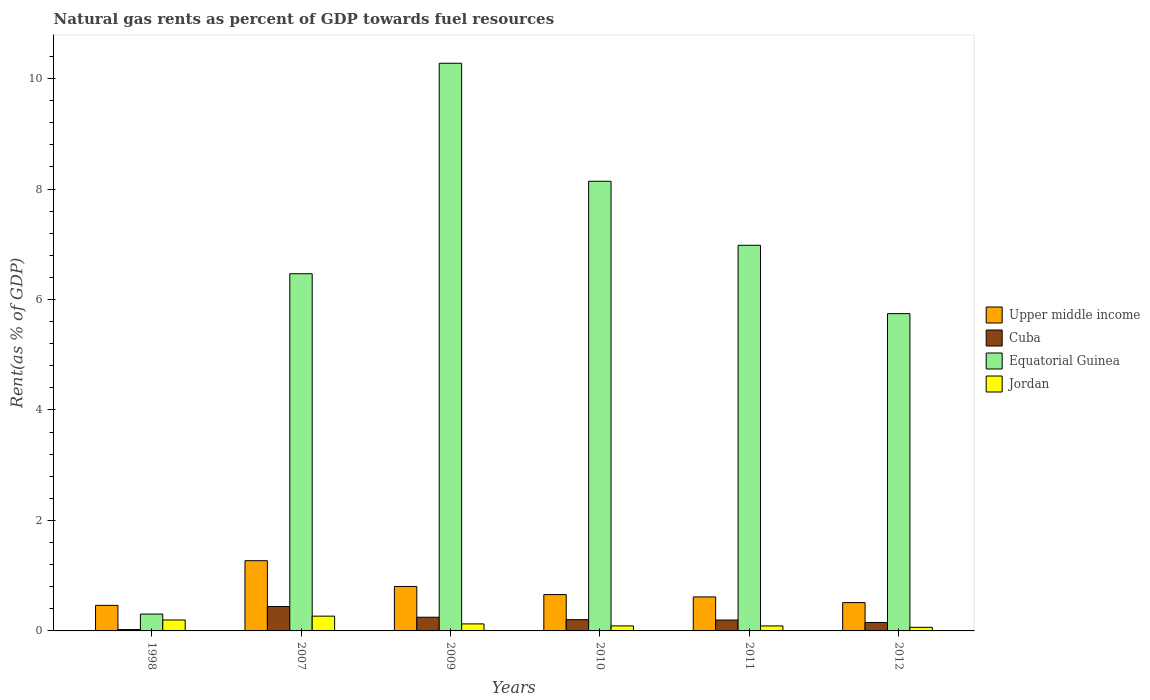How many different coloured bars are there?
Provide a succinct answer. 4. How many groups of bars are there?
Your response must be concise. 6. Are the number of bars per tick equal to the number of legend labels?
Your answer should be very brief. Yes. In how many cases, is the number of bars for a given year not equal to the number of legend labels?
Ensure brevity in your answer.  0. What is the matural gas rent in Cuba in 2010?
Provide a short and direct response. 0.2. Across all years, what is the maximum matural gas rent in Upper middle income?
Your answer should be very brief. 1.27. Across all years, what is the minimum matural gas rent in Equatorial Guinea?
Your answer should be compact. 0.31. In which year was the matural gas rent in Cuba maximum?
Your response must be concise. 2007. What is the total matural gas rent in Jordan in the graph?
Offer a very short reply. 0.84. What is the difference between the matural gas rent in Upper middle income in 2010 and that in 2011?
Your response must be concise. 0.04. What is the difference between the matural gas rent in Jordan in 2007 and the matural gas rent in Equatorial Guinea in 2012?
Your answer should be compact. -5.48. What is the average matural gas rent in Jordan per year?
Ensure brevity in your answer.  0.14. In the year 2007, what is the difference between the matural gas rent in Upper middle income and matural gas rent in Equatorial Guinea?
Offer a very short reply. -5.2. In how many years, is the matural gas rent in Equatorial Guinea greater than 2 %?
Provide a succinct answer. 5. What is the ratio of the matural gas rent in Jordan in 2011 to that in 2012?
Your response must be concise. 1.38. Is the matural gas rent in Equatorial Guinea in 2007 less than that in 2011?
Your answer should be compact. Yes. Is the difference between the matural gas rent in Upper middle income in 1998 and 2010 greater than the difference between the matural gas rent in Equatorial Guinea in 1998 and 2010?
Make the answer very short. Yes. What is the difference between the highest and the second highest matural gas rent in Equatorial Guinea?
Your answer should be very brief. 2.14. What is the difference between the highest and the lowest matural gas rent in Jordan?
Keep it short and to the point. 0.2. What does the 4th bar from the left in 2007 represents?
Your answer should be compact. Jordan. What does the 4th bar from the right in 1998 represents?
Provide a succinct answer. Upper middle income. How many bars are there?
Offer a terse response. 24. Does the graph contain any zero values?
Keep it short and to the point. No. Does the graph contain grids?
Make the answer very short. No. Where does the legend appear in the graph?
Provide a succinct answer. Center right. How are the legend labels stacked?
Give a very brief answer. Vertical. What is the title of the graph?
Ensure brevity in your answer.  Natural gas rents as percent of GDP towards fuel resources. Does "Cayman Islands" appear as one of the legend labels in the graph?
Keep it short and to the point. No. What is the label or title of the X-axis?
Provide a succinct answer. Years. What is the label or title of the Y-axis?
Provide a succinct answer. Rent(as % of GDP). What is the Rent(as % of GDP) of Upper middle income in 1998?
Your response must be concise. 0.46. What is the Rent(as % of GDP) in Cuba in 1998?
Make the answer very short. 0.02. What is the Rent(as % of GDP) in Equatorial Guinea in 1998?
Ensure brevity in your answer.  0.31. What is the Rent(as % of GDP) of Jordan in 1998?
Ensure brevity in your answer.  0.2. What is the Rent(as % of GDP) in Upper middle income in 2007?
Ensure brevity in your answer.  1.27. What is the Rent(as % of GDP) of Cuba in 2007?
Your answer should be very brief. 0.44. What is the Rent(as % of GDP) of Equatorial Guinea in 2007?
Keep it short and to the point. 6.47. What is the Rent(as % of GDP) in Jordan in 2007?
Give a very brief answer. 0.27. What is the Rent(as % of GDP) of Upper middle income in 2009?
Keep it short and to the point. 0.8. What is the Rent(as % of GDP) of Cuba in 2009?
Ensure brevity in your answer.  0.25. What is the Rent(as % of GDP) in Equatorial Guinea in 2009?
Provide a short and direct response. 10.28. What is the Rent(as % of GDP) in Jordan in 2009?
Provide a succinct answer. 0.13. What is the Rent(as % of GDP) of Upper middle income in 2010?
Your answer should be compact. 0.66. What is the Rent(as % of GDP) in Cuba in 2010?
Offer a very short reply. 0.2. What is the Rent(as % of GDP) of Equatorial Guinea in 2010?
Provide a short and direct response. 8.14. What is the Rent(as % of GDP) in Jordan in 2010?
Your response must be concise. 0.09. What is the Rent(as % of GDP) in Upper middle income in 2011?
Keep it short and to the point. 0.62. What is the Rent(as % of GDP) in Cuba in 2011?
Give a very brief answer. 0.2. What is the Rent(as % of GDP) of Equatorial Guinea in 2011?
Your answer should be very brief. 6.98. What is the Rent(as % of GDP) in Jordan in 2011?
Your answer should be very brief. 0.09. What is the Rent(as % of GDP) of Upper middle income in 2012?
Provide a short and direct response. 0.51. What is the Rent(as % of GDP) in Cuba in 2012?
Make the answer very short. 0.15. What is the Rent(as % of GDP) in Equatorial Guinea in 2012?
Provide a succinct answer. 5.74. What is the Rent(as % of GDP) of Jordan in 2012?
Your answer should be very brief. 0.07. Across all years, what is the maximum Rent(as % of GDP) in Upper middle income?
Provide a short and direct response. 1.27. Across all years, what is the maximum Rent(as % of GDP) in Cuba?
Your response must be concise. 0.44. Across all years, what is the maximum Rent(as % of GDP) of Equatorial Guinea?
Provide a succinct answer. 10.28. Across all years, what is the maximum Rent(as % of GDP) of Jordan?
Ensure brevity in your answer.  0.27. Across all years, what is the minimum Rent(as % of GDP) of Upper middle income?
Your answer should be compact. 0.46. Across all years, what is the minimum Rent(as % of GDP) in Cuba?
Provide a succinct answer. 0.02. Across all years, what is the minimum Rent(as % of GDP) in Equatorial Guinea?
Your response must be concise. 0.31. Across all years, what is the minimum Rent(as % of GDP) in Jordan?
Make the answer very short. 0.07. What is the total Rent(as % of GDP) of Upper middle income in the graph?
Provide a short and direct response. 4.33. What is the total Rent(as % of GDP) in Cuba in the graph?
Ensure brevity in your answer.  1.27. What is the total Rent(as % of GDP) in Equatorial Guinea in the graph?
Provide a succinct answer. 37.92. What is the total Rent(as % of GDP) of Jordan in the graph?
Ensure brevity in your answer.  0.84. What is the difference between the Rent(as % of GDP) of Upper middle income in 1998 and that in 2007?
Provide a short and direct response. -0.81. What is the difference between the Rent(as % of GDP) of Cuba in 1998 and that in 2007?
Keep it short and to the point. -0.42. What is the difference between the Rent(as % of GDP) in Equatorial Guinea in 1998 and that in 2007?
Your response must be concise. -6.16. What is the difference between the Rent(as % of GDP) in Jordan in 1998 and that in 2007?
Your answer should be compact. -0.07. What is the difference between the Rent(as % of GDP) of Upper middle income in 1998 and that in 2009?
Ensure brevity in your answer.  -0.34. What is the difference between the Rent(as % of GDP) of Cuba in 1998 and that in 2009?
Offer a terse response. -0.22. What is the difference between the Rent(as % of GDP) of Equatorial Guinea in 1998 and that in 2009?
Your response must be concise. -9.97. What is the difference between the Rent(as % of GDP) in Jordan in 1998 and that in 2009?
Offer a terse response. 0.07. What is the difference between the Rent(as % of GDP) of Upper middle income in 1998 and that in 2010?
Give a very brief answer. -0.2. What is the difference between the Rent(as % of GDP) in Cuba in 1998 and that in 2010?
Ensure brevity in your answer.  -0.18. What is the difference between the Rent(as % of GDP) of Equatorial Guinea in 1998 and that in 2010?
Keep it short and to the point. -7.84. What is the difference between the Rent(as % of GDP) of Jordan in 1998 and that in 2010?
Offer a terse response. 0.11. What is the difference between the Rent(as % of GDP) of Upper middle income in 1998 and that in 2011?
Offer a very short reply. -0.15. What is the difference between the Rent(as % of GDP) of Cuba in 1998 and that in 2011?
Make the answer very short. -0.17. What is the difference between the Rent(as % of GDP) in Equatorial Guinea in 1998 and that in 2011?
Your answer should be very brief. -6.68. What is the difference between the Rent(as % of GDP) of Jordan in 1998 and that in 2011?
Your answer should be very brief. 0.11. What is the difference between the Rent(as % of GDP) of Upper middle income in 1998 and that in 2012?
Provide a short and direct response. -0.05. What is the difference between the Rent(as % of GDP) of Cuba in 1998 and that in 2012?
Keep it short and to the point. -0.13. What is the difference between the Rent(as % of GDP) of Equatorial Guinea in 1998 and that in 2012?
Provide a short and direct response. -5.44. What is the difference between the Rent(as % of GDP) of Jordan in 1998 and that in 2012?
Your answer should be very brief. 0.13. What is the difference between the Rent(as % of GDP) of Upper middle income in 2007 and that in 2009?
Give a very brief answer. 0.47. What is the difference between the Rent(as % of GDP) of Cuba in 2007 and that in 2009?
Provide a succinct answer. 0.19. What is the difference between the Rent(as % of GDP) in Equatorial Guinea in 2007 and that in 2009?
Keep it short and to the point. -3.81. What is the difference between the Rent(as % of GDP) in Jordan in 2007 and that in 2009?
Your answer should be compact. 0.14. What is the difference between the Rent(as % of GDP) of Upper middle income in 2007 and that in 2010?
Offer a terse response. 0.61. What is the difference between the Rent(as % of GDP) in Cuba in 2007 and that in 2010?
Ensure brevity in your answer.  0.24. What is the difference between the Rent(as % of GDP) of Equatorial Guinea in 2007 and that in 2010?
Provide a short and direct response. -1.67. What is the difference between the Rent(as % of GDP) in Jordan in 2007 and that in 2010?
Give a very brief answer. 0.18. What is the difference between the Rent(as % of GDP) of Upper middle income in 2007 and that in 2011?
Keep it short and to the point. 0.66. What is the difference between the Rent(as % of GDP) in Cuba in 2007 and that in 2011?
Give a very brief answer. 0.24. What is the difference between the Rent(as % of GDP) in Equatorial Guinea in 2007 and that in 2011?
Give a very brief answer. -0.51. What is the difference between the Rent(as % of GDP) in Jordan in 2007 and that in 2011?
Ensure brevity in your answer.  0.18. What is the difference between the Rent(as % of GDP) in Upper middle income in 2007 and that in 2012?
Offer a terse response. 0.76. What is the difference between the Rent(as % of GDP) in Cuba in 2007 and that in 2012?
Give a very brief answer. 0.29. What is the difference between the Rent(as % of GDP) in Equatorial Guinea in 2007 and that in 2012?
Ensure brevity in your answer.  0.72. What is the difference between the Rent(as % of GDP) in Jordan in 2007 and that in 2012?
Provide a succinct answer. 0.2. What is the difference between the Rent(as % of GDP) in Upper middle income in 2009 and that in 2010?
Provide a succinct answer. 0.15. What is the difference between the Rent(as % of GDP) in Cuba in 2009 and that in 2010?
Offer a terse response. 0.04. What is the difference between the Rent(as % of GDP) of Equatorial Guinea in 2009 and that in 2010?
Your response must be concise. 2.14. What is the difference between the Rent(as % of GDP) in Jordan in 2009 and that in 2010?
Offer a terse response. 0.04. What is the difference between the Rent(as % of GDP) of Upper middle income in 2009 and that in 2011?
Give a very brief answer. 0.19. What is the difference between the Rent(as % of GDP) of Cuba in 2009 and that in 2011?
Offer a terse response. 0.05. What is the difference between the Rent(as % of GDP) of Equatorial Guinea in 2009 and that in 2011?
Provide a short and direct response. 3.3. What is the difference between the Rent(as % of GDP) of Jordan in 2009 and that in 2011?
Your response must be concise. 0.04. What is the difference between the Rent(as % of GDP) of Upper middle income in 2009 and that in 2012?
Provide a short and direct response. 0.29. What is the difference between the Rent(as % of GDP) of Cuba in 2009 and that in 2012?
Offer a very short reply. 0.1. What is the difference between the Rent(as % of GDP) in Equatorial Guinea in 2009 and that in 2012?
Make the answer very short. 4.53. What is the difference between the Rent(as % of GDP) in Jordan in 2009 and that in 2012?
Give a very brief answer. 0.06. What is the difference between the Rent(as % of GDP) of Upper middle income in 2010 and that in 2011?
Provide a short and direct response. 0.04. What is the difference between the Rent(as % of GDP) of Cuba in 2010 and that in 2011?
Offer a very short reply. 0.01. What is the difference between the Rent(as % of GDP) of Equatorial Guinea in 2010 and that in 2011?
Provide a succinct answer. 1.16. What is the difference between the Rent(as % of GDP) of Upper middle income in 2010 and that in 2012?
Your response must be concise. 0.15. What is the difference between the Rent(as % of GDP) in Cuba in 2010 and that in 2012?
Offer a terse response. 0.05. What is the difference between the Rent(as % of GDP) of Equatorial Guinea in 2010 and that in 2012?
Offer a very short reply. 2.4. What is the difference between the Rent(as % of GDP) in Jordan in 2010 and that in 2012?
Provide a succinct answer. 0.03. What is the difference between the Rent(as % of GDP) in Upper middle income in 2011 and that in 2012?
Offer a very short reply. 0.1. What is the difference between the Rent(as % of GDP) of Cuba in 2011 and that in 2012?
Give a very brief answer. 0.04. What is the difference between the Rent(as % of GDP) in Equatorial Guinea in 2011 and that in 2012?
Your answer should be compact. 1.24. What is the difference between the Rent(as % of GDP) in Jordan in 2011 and that in 2012?
Give a very brief answer. 0.02. What is the difference between the Rent(as % of GDP) in Upper middle income in 1998 and the Rent(as % of GDP) in Cuba in 2007?
Your response must be concise. 0.02. What is the difference between the Rent(as % of GDP) of Upper middle income in 1998 and the Rent(as % of GDP) of Equatorial Guinea in 2007?
Give a very brief answer. -6. What is the difference between the Rent(as % of GDP) of Upper middle income in 1998 and the Rent(as % of GDP) of Jordan in 2007?
Your answer should be very brief. 0.2. What is the difference between the Rent(as % of GDP) of Cuba in 1998 and the Rent(as % of GDP) of Equatorial Guinea in 2007?
Your response must be concise. -6.44. What is the difference between the Rent(as % of GDP) in Cuba in 1998 and the Rent(as % of GDP) in Jordan in 2007?
Make the answer very short. -0.24. What is the difference between the Rent(as % of GDP) of Equatorial Guinea in 1998 and the Rent(as % of GDP) of Jordan in 2007?
Your answer should be very brief. 0.04. What is the difference between the Rent(as % of GDP) of Upper middle income in 1998 and the Rent(as % of GDP) of Cuba in 2009?
Provide a succinct answer. 0.21. What is the difference between the Rent(as % of GDP) of Upper middle income in 1998 and the Rent(as % of GDP) of Equatorial Guinea in 2009?
Provide a short and direct response. -9.81. What is the difference between the Rent(as % of GDP) of Upper middle income in 1998 and the Rent(as % of GDP) of Jordan in 2009?
Your response must be concise. 0.34. What is the difference between the Rent(as % of GDP) in Cuba in 1998 and the Rent(as % of GDP) in Equatorial Guinea in 2009?
Offer a terse response. -10.25. What is the difference between the Rent(as % of GDP) in Cuba in 1998 and the Rent(as % of GDP) in Jordan in 2009?
Make the answer very short. -0.1. What is the difference between the Rent(as % of GDP) of Equatorial Guinea in 1998 and the Rent(as % of GDP) of Jordan in 2009?
Give a very brief answer. 0.18. What is the difference between the Rent(as % of GDP) of Upper middle income in 1998 and the Rent(as % of GDP) of Cuba in 2010?
Make the answer very short. 0.26. What is the difference between the Rent(as % of GDP) of Upper middle income in 1998 and the Rent(as % of GDP) of Equatorial Guinea in 2010?
Give a very brief answer. -7.68. What is the difference between the Rent(as % of GDP) of Upper middle income in 1998 and the Rent(as % of GDP) of Jordan in 2010?
Offer a terse response. 0.37. What is the difference between the Rent(as % of GDP) in Cuba in 1998 and the Rent(as % of GDP) in Equatorial Guinea in 2010?
Provide a succinct answer. -8.12. What is the difference between the Rent(as % of GDP) in Cuba in 1998 and the Rent(as % of GDP) in Jordan in 2010?
Provide a succinct answer. -0.07. What is the difference between the Rent(as % of GDP) of Equatorial Guinea in 1998 and the Rent(as % of GDP) of Jordan in 2010?
Keep it short and to the point. 0.21. What is the difference between the Rent(as % of GDP) of Upper middle income in 1998 and the Rent(as % of GDP) of Cuba in 2011?
Keep it short and to the point. 0.27. What is the difference between the Rent(as % of GDP) in Upper middle income in 1998 and the Rent(as % of GDP) in Equatorial Guinea in 2011?
Offer a very short reply. -6.52. What is the difference between the Rent(as % of GDP) of Upper middle income in 1998 and the Rent(as % of GDP) of Jordan in 2011?
Your response must be concise. 0.37. What is the difference between the Rent(as % of GDP) in Cuba in 1998 and the Rent(as % of GDP) in Equatorial Guinea in 2011?
Your answer should be compact. -6.96. What is the difference between the Rent(as % of GDP) of Cuba in 1998 and the Rent(as % of GDP) of Jordan in 2011?
Your answer should be compact. -0.07. What is the difference between the Rent(as % of GDP) of Equatorial Guinea in 1998 and the Rent(as % of GDP) of Jordan in 2011?
Your answer should be very brief. 0.21. What is the difference between the Rent(as % of GDP) of Upper middle income in 1998 and the Rent(as % of GDP) of Cuba in 2012?
Make the answer very short. 0.31. What is the difference between the Rent(as % of GDP) in Upper middle income in 1998 and the Rent(as % of GDP) in Equatorial Guinea in 2012?
Offer a very short reply. -5.28. What is the difference between the Rent(as % of GDP) in Upper middle income in 1998 and the Rent(as % of GDP) in Jordan in 2012?
Your response must be concise. 0.4. What is the difference between the Rent(as % of GDP) of Cuba in 1998 and the Rent(as % of GDP) of Equatorial Guinea in 2012?
Provide a short and direct response. -5.72. What is the difference between the Rent(as % of GDP) of Cuba in 1998 and the Rent(as % of GDP) of Jordan in 2012?
Your answer should be very brief. -0.04. What is the difference between the Rent(as % of GDP) of Equatorial Guinea in 1998 and the Rent(as % of GDP) of Jordan in 2012?
Your answer should be very brief. 0.24. What is the difference between the Rent(as % of GDP) in Upper middle income in 2007 and the Rent(as % of GDP) in Cuba in 2009?
Offer a very short reply. 1.02. What is the difference between the Rent(as % of GDP) of Upper middle income in 2007 and the Rent(as % of GDP) of Equatorial Guinea in 2009?
Keep it short and to the point. -9.01. What is the difference between the Rent(as % of GDP) in Upper middle income in 2007 and the Rent(as % of GDP) in Jordan in 2009?
Provide a short and direct response. 1.14. What is the difference between the Rent(as % of GDP) in Cuba in 2007 and the Rent(as % of GDP) in Equatorial Guinea in 2009?
Keep it short and to the point. -9.84. What is the difference between the Rent(as % of GDP) in Cuba in 2007 and the Rent(as % of GDP) in Jordan in 2009?
Your answer should be very brief. 0.31. What is the difference between the Rent(as % of GDP) of Equatorial Guinea in 2007 and the Rent(as % of GDP) of Jordan in 2009?
Your answer should be compact. 6.34. What is the difference between the Rent(as % of GDP) in Upper middle income in 2007 and the Rent(as % of GDP) in Cuba in 2010?
Your response must be concise. 1.07. What is the difference between the Rent(as % of GDP) in Upper middle income in 2007 and the Rent(as % of GDP) in Equatorial Guinea in 2010?
Your response must be concise. -6.87. What is the difference between the Rent(as % of GDP) in Upper middle income in 2007 and the Rent(as % of GDP) in Jordan in 2010?
Offer a very short reply. 1.18. What is the difference between the Rent(as % of GDP) of Cuba in 2007 and the Rent(as % of GDP) of Equatorial Guinea in 2010?
Make the answer very short. -7.7. What is the difference between the Rent(as % of GDP) in Cuba in 2007 and the Rent(as % of GDP) in Jordan in 2010?
Your response must be concise. 0.35. What is the difference between the Rent(as % of GDP) in Equatorial Guinea in 2007 and the Rent(as % of GDP) in Jordan in 2010?
Give a very brief answer. 6.38. What is the difference between the Rent(as % of GDP) of Upper middle income in 2007 and the Rent(as % of GDP) of Cuba in 2011?
Provide a succinct answer. 1.07. What is the difference between the Rent(as % of GDP) in Upper middle income in 2007 and the Rent(as % of GDP) in Equatorial Guinea in 2011?
Ensure brevity in your answer.  -5.71. What is the difference between the Rent(as % of GDP) in Upper middle income in 2007 and the Rent(as % of GDP) in Jordan in 2011?
Your answer should be compact. 1.18. What is the difference between the Rent(as % of GDP) of Cuba in 2007 and the Rent(as % of GDP) of Equatorial Guinea in 2011?
Ensure brevity in your answer.  -6.54. What is the difference between the Rent(as % of GDP) of Cuba in 2007 and the Rent(as % of GDP) of Jordan in 2011?
Make the answer very short. 0.35. What is the difference between the Rent(as % of GDP) of Equatorial Guinea in 2007 and the Rent(as % of GDP) of Jordan in 2011?
Offer a terse response. 6.38. What is the difference between the Rent(as % of GDP) of Upper middle income in 2007 and the Rent(as % of GDP) of Cuba in 2012?
Your answer should be compact. 1.12. What is the difference between the Rent(as % of GDP) in Upper middle income in 2007 and the Rent(as % of GDP) in Equatorial Guinea in 2012?
Provide a succinct answer. -4.47. What is the difference between the Rent(as % of GDP) of Upper middle income in 2007 and the Rent(as % of GDP) of Jordan in 2012?
Give a very brief answer. 1.21. What is the difference between the Rent(as % of GDP) of Cuba in 2007 and the Rent(as % of GDP) of Equatorial Guinea in 2012?
Offer a very short reply. -5.3. What is the difference between the Rent(as % of GDP) of Cuba in 2007 and the Rent(as % of GDP) of Jordan in 2012?
Offer a very short reply. 0.38. What is the difference between the Rent(as % of GDP) in Equatorial Guinea in 2007 and the Rent(as % of GDP) in Jordan in 2012?
Keep it short and to the point. 6.4. What is the difference between the Rent(as % of GDP) of Upper middle income in 2009 and the Rent(as % of GDP) of Cuba in 2010?
Make the answer very short. 0.6. What is the difference between the Rent(as % of GDP) in Upper middle income in 2009 and the Rent(as % of GDP) in Equatorial Guinea in 2010?
Offer a very short reply. -7.34. What is the difference between the Rent(as % of GDP) of Upper middle income in 2009 and the Rent(as % of GDP) of Jordan in 2010?
Give a very brief answer. 0.71. What is the difference between the Rent(as % of GDP) of Cuba in 2009 and the Rent(as % of GDP) of Equatorial Guinea in 2010?
Your answer should be compact. -7.89. What is the difference between the Rent(as % of GDP) in Cuba in 2009 and the Rent(as % of GDP) in Jordan in 2010?
Your answer should be very brief. 0.16. What is the difference between the Rent(as % of GDP) in Equatorial Guinea in 2009 and the Rent(as % of GDP) in Jordan in 2010?
Make the answer very short. 10.19. What is the difference between the Rent(as % of GDP) in Upper middle income in 2009 and the Rent(as % of GDP) in Cuba in 2011?
Your response must be concise. 0.61. What is the difference between the Rent(as % of GDP) of Upper middle income in 2009 and the Rent(as % of GDP) of Equatorial Guinea in 2011?
Provide a succinct answer. -6.18. What is the difference between the Rent(as % of GDP) of Upper middle income in 2009 and the Rent(as % of GDP) of Jordan in 2011?
Ensure brevity in your answer.  0.71. What is the difference between the Rent(as % of GDP) in Cuba in 2009 and the Rent(as % of GDP) in Equatorial Guinea in 2011?
Ensure brevity in your answer.  -6.73. What is the difference between the Rent(as % of GDP) in Cuba in 2009 and the Rent(as % of GDP) in Jordan in 2011?
Your answer should be compact. 0.16. What is the difference between the Rent(as % of GDP) in Equatorial Guinea in 2009 and the Rent(as % of GDP) in Jordan in 2011?
Your answer should be compact. 10.19. What is the difference between the Rent(as % of GDP) of Upper middle income in 2009 and the Rent(as % of GDP) of Cuba in 2012?
Keep it short and to the point. 0.65. What is the difference between the Rent(as % of GDP) in Upper middle income in 2009 and the Rent(as % of GDP) in Equatorial Guinea in 2012?
Keep it short and to the point. -4.94. What is the difference between the Rent(as % of GDP) of Upper middle income in 2009 and the Rent(as % of GDP) of Jordan in 2012?
Your answer should be very brief. 0.74. What is the difference between the Rent(as % of GDP) of Cuba in 2009 and the Rent(as % of GDP) of Equatorial Guinea in 2012?
Give a very brief answer. -5.5. What is the difference between the Rent(as % of GDP) of Cuba in 2009 and the Rent(as % of GDP) of Jordan in 2012?
Make the answer very short. 0.18. What is the difference between the Rent(as % of GDP) in Equatorial Guinea in 2009 and the Rent(as % of GDP) in Jordan in 2012?
Your response must be concise. 10.21. What is the difference between the Rent(as % of GDP) of Upper middle income in 2010 and the Rent(as % of GDP) of Cuba in 2011?
Keep it short and to the point. 0.46. What is the difference between the Rent(as % of GDP) of Upper middle income in 2010 and the Rent(as % of GDP) of Equatorial Guinea in 2011?
Your answer should be compact. -6.32. What is the difference between the Rent(as % of GDP) of Upper middle income in 2010 and the Rent(as % of GDP) of Jordan in 2011?
Your response must be concise. 0.57. What is the difference between the Rent(as % of GDP) in Cuba in 2010 and the Rent(as % of GDP) in Equatorial Guinea in 2011?
Provide a short and direct response. -6.78. What is the difference between the Rent(as % of GDP) in Cuba in 2010 and the Rent(as % of GDP) in Jordan in 2011?
Your answer should be compact. 0.11. What is the difference between the Rent(as % of GDP) in Equatorial Guinea in 2010 and the Rent(as % of GDP) in Jordan in 2011?
Keep it short and to the point. 8.05. What is the difference between the Rent(as % of GDP) in Upper middle income in 2010 and the Rent(as % of GDP) in Cuba in 2012?
Your answer should be very brief. 0.51. What is the difference between the Rent(as % of GDP) in Upper middle income in 2010 and the Rent(as % of GDP) in Equatorial Guinea in 2012?
Your response must be concise. -5.09. What is the difference between the Rent(as % of GDP) of Upper middle income in 2010 and the Rent(as % of GDP) of Jordan in 2012?
Provide a succinct answer. 0.59. What is the difference between the Rent(as % of GDP) in Cuba in 2010 and the Rent(as % of GDP) in Equatorial Guinea in 2012?
Offer a very short reply. -5.54. What is the difference between the Rent(as % of GDP) in Cuba in 2010 and the Rent(as % of GDP) in Jordan in 2012?
Give a very brief answer. 0.14. What is the difference between the Rent(as % of GDP) of Equatorial Guinea in 2010 and the Rent(as % of GDP) of Jordan in 2012?
Ensure brevity in your answer.  8.08. What is the difference between the Rent(as % of GDP) in Upper middle income in 2011 and the Rent(as % of GDP) in Cuba in 2012?
Ensure brevity in your answer.  0.46. What is the difference between the Rent(as % of GDP) in Upper middle income in 2011 and the Rent(as % of GDP) in Equatorial Guinea in 2012?
Your answer should be very brief. -5.13. What is the difference between the Rent(as % of GDP) in Upper middle income in 2011 and the Rent(as % of GDP) in Jordan in 2012?
Keep it short and to the point. 0.55. What is the difference between the Rent(as % of GDP) of Cuba in 2011 and the Rent(as % of GDP) of Equatorial Guinea in 2012?
Offer a very short reply. -5.55. What is the difference between the Rent(as % of GDP) in Cuba in 2011 and the Rent(as % of GDP) in Jordan in 2012?
Provide a succinct answer. 0.13. What is the difference between the Rent(as % of GDP) in Equatorial Guinea in 2011 and the Rent(as % of GDP) in Jordan in 2012?
Ensure brevity in your answer.  6.92. What is the average Rent(as % of GDP) of Upper middle income per year?
Give a very brief answer. 0.72. What is the average Rent(as % of GDP) in Cuba per year?
Offer a very short reply. 0.21. What is the average Rent(as % of GDP) in Equatorial Guinea per year?
Your answer should be compact. 6.32. What is the average Rent(as % of GDP) of Jordan per year?
Your answer should be very brief. 0.14. In the year 1998, what is the difference between the Rent(as % of GDP) of Upper middle income and Rent(as % of GDP) of Cuba?
Provide a short and direct response. 0.44. In the year 1998, what is the difference between the Rent(as % of GDP) in Upper middle income and Rent(as % of GDP) in Equatorial Guinea?
Provide a short and direct response. 0.16. In the year 1998, what is the difference between the Rent(as % of GDP) in Upper middle income and Rent(as % of GDP) in Jordan?
Provide a succinct answer. 0.26. In the year 1998, what is the difference between the Rent(as % of GDP) in Cuba and Rent(as % of GDP) in Equatorial Guinea?
Provide a succinct answer. -0.28. In the year 1998, what is the difference between the Rent(as % of GDP) of Cuba and Rent(as % of GDP) of Jordan?
Give a very brief answer. -0.17. In the year 1998, what is the difference between the Rent(as % of GDP) in Equatorial Guinea and Rent(as % of GDP) in Jordan?
Offer a terse response. 0.11. In the year 2007, what is the difference between the Rent(as % of GDP) of Upper middle income and Rent(as % of GDP) of Cuba?
Ensure brevity in your answer.  0.83. In the year 2007, what is the difference between the Rent(as % of GDP) of Upper middle income and Rent(as % of GDP) of Equatorial Guinea?
Your response must be concise. -5.2. In the year 2007, what is the difference between the Rent(as % of GDP) in Cuba and Rent(as % of GDP) in Equatorial Guinea?
Your answer should be compact. -6.03. In the year 2007, what is the difference between the Rent(as % of GDP) of Cuba and Rent(as % of GDP) of Jordan?
Your answer should be very brief. 0.17. In the year 2007, what is the difference between the Rent(as % of GDP) of Equatorial Guinea and Rent(as % of GDP) of Jordan?
Keep it short and to the point. 6.2. In the year 2009, what is the difference between the Rent(as % of GDP) in Upper middle income and Rent(as % of GDP) in Cuba?
Keep it short and to the point. 0.56. In the year 2009, what is the difference between the Rent(as % of GDP) of Upper middle income and Rent(as % of GDP) of Equatorial Guinea?
Keep it short and to the point. -9.47. In the year 2009, what is the difference between the Rent(as % of GDP) in Upper middle income and Rent(as % of GDP) in Jordan?
Offer a terse response. 0.68. In the year 2009, what is the difference between the Rent(as % of GDP) of Cuba and Rent(as % of GDP) of Equatorial Guinea?
Your response must be concise. -10.03. In the year 2009, what is the difference between the Rent(as % of GDP) in Cuba and Rent(as % of GDP) in Jordan?
Your answer should be very brief. 0.12. In the year 2009, what is the difference between the Rent(as % of GDP) in Equatorial Guinea and Rent(as % of GDP) in Jordan?
Make the answer very short. 10.15. In the year 2010, what is the difference between the Rent(as % of GDP) in Upper middle income and Rent(as % of GDP) in Cuba?
Give a very brief answer. 0.45. In the year 2010, what is the difference between the Rent(as % of GDP) in Upper middle income and Rent(as % of GDP) in Equatorial Guinea?
Your answer should be compact. -7.48. In the year 2010, what is the difference between the Rent(as % of GDP) of Upper middle income and Rent(as % of GDP) of Jordan?
Your response must be concise. 0.57. In the year 2010, what is the difference between the Rent(as % of GDP) of Cuba and Rent(as % of GDP) of Equatorial Guinea?
Your answer should be compact. -7.94. In the year 2010, what is the difference between the Rent(as % of GDP) in Cuba and Rent(as % of GDP) in Jordan?
Your response must be concise. 0.11. In the year 2010, what is the difference between the Rent(as % of GDP) in Equatorial Guinea and Rent(as % of GDP) in Jordan?
Ensure brevity in your answer.  8.05. In the year 2011, what is the difference between the Rent(as % of GDP) in Upper middle income and Rent(as % of GDP) in Cuba?
Ensure brevity in your answer.  0.42. In the year 2011, what is the difference between the Rent(as % of GDP) of Upper middle income and Rent(as % of GDP) of Equatorial Guinea?
Offer a very short reply. -6.37. In the year 2011, what is the difference between the Rent(as % of GDP) of Upper middle income and Rent(as % of GDP) of Jordan?
Make the answer very short. 0.53. In the year 2011, what is the difference between the Rent(as % of GDP) in Cuba and Rent(as % of GDP) in Equatorial Guinea?
Your answer should be compact. -6.78. In the year 2011, what is the difference between the Rent(as % of GDP) in Cuba and Rent(as % of GDP) in Jordan?
Your response must be concise. 0.11. In the year 2011, what is the difference between the Rent(as % of GDP) in Equatorial Guinea and Rent(as % of GDP) in Jordan?
Your response must be concise. 6.89. In the year 2012, what is the difference between the Rent(as % of GDP) of Upper middle income and Rent(as % of GDP) of Cuba?
Provide a succinct answer. 0.36. In the year 2012, what is the difference between the Rent(as % of GDP) in Upper middle income and Rent(as % of GDP) in Equatorial Guinea?
Provide a succinct answer. -5.23. In the year 2012, what is the difference between the Rent(as % of GDP) of Upper middle income and Rent(as % of GDP) of Jordan?
Your answer should be compact. 0.45. In the year 2012, what is the difference between the Rent(as % of GDP) in Cuba and Rent(as % of GDP) in Equatorial Guinea?
Offer a very short reply. -5.59. In the year 2012, what is the difference between the Rent(as % of GDP) in Cuba and Rent(as % of GDP) in Jordan?
Give a very brief answer. 0.09. In the year 2012, what is the difference between the Rent(as % of GDP) of Equatorial Guinea and Rent(as % of GDP) of Jordan?
Offer a very short reply. 5.68. What is the ratio of the Rent(as % of GDP) of Upper middle income in 1998 to that in 2007?
Ensure brevity in your answer.  0.36. What is the ratio of the Rent(as % of GDP) in Cuba in 1998 to that in 2007?
Your answer should be very brief. 0.05. What is the ratio of the Rent(as % of GDP) of Equatorial Guinea in 1998 to that in 2007?
Your response must be concise. 0.05. What is the ratio of the Rent(as % of GDP) in Jordan in 1998 to that in 2007?
Offer a terse response. 0.74. What is the ratio of the Rent(as % of GDP) in Upper middle income in 1998 to that in 2009?
Give a very brief answer. 0.57. What is the ratio of the Rent(as % of GDP) of Cuba in 1998 to that in 2009?
Provide a short and direct response. 0.1. What is the ratio of the Rent(as % of GDP) in Equatorial Guinea in 1998 to that in 2009?
Offer a terse response. 0.03. What is the ratio of the Rent(as % of GDP) of Jordan in 1998 to that in 2009?
Give a very brief answer. 1.55. What is the ratio of the Rent(as % of GDP) in Upper middle income in 1998 to that in 2010?
Ensure brevity in your answer.  0.7. What is the ratio of the Rent(as % of GDP) of Cuba in 1998 to that in 2010?
Your answer should be very brief. 0.12. What is the ratio of the Rent(as % of GDP) of Equatorial Guinea in 1998 to that in 2010?
Ensure brevity in your answer.  0.04. What is the ratio of the Rent(as % of GDP) of Jordan in 1998 to that in 2010?
Offer a very short reply. 2.18. What is the ratio of the Rent(as % of GDP) in Upper middle income in 1998 to that in 2011?
Offer a very short reply. 0.75. What is the ratio of the Rent(as % of GDP) of Cuba in 1998 to that in 2011?
Your response must be concise. 0.12. What is the ratio of the Rent(as % of GDP) in Equatorial Guinea in 1998 to that in 2011?
Provide a short and direct response. 0.04. What is the ratio of the Rent(as % of GDP) in Jordan in 1998 to that in 2011?
Offer a very short reply. 2.19. What is the ratio of the Rent(as % of GDP) in Upper middle income in 1998 to that in 2012?
Keep it short and to the point. 0.9. What is the ratio of the Rent(as % of GDP) in Cuba in 1998 to that in 2012?
Provide a succinct answer. 0.16. What is the ratio of the Rent(as % of GDP) of Equatorial Guinea in 1998 to that in 2012?
Offer a very short reply. 0.05. What is the ratio of the Rent(as % of GDP) in Jordan in 1998 to that in 2012?
Keep it short and to the point. 3.03. What is the ratio of the Rent(as % of GDP) in Upper middle income in 2007 to that in 2009?
Keep it short and to the point. 1.58. What is the ratio of the Rent(as % of GDP) of Cuba in 2007 to that in 2009?
Keep it short and to the point. 1.78. What is the ratio of the Rent(as % of GDP) of Equatorial Guinea in 2007 to that in 2009?
Your answer should be very brief. 0.63. What is the ratio of the Rent(as % of GDP) in Jordan in 2007 to that in 2009?
Give a very brief answer. 2.1. What is the ratio of the Rent(as % of GDP) in Upper middle income in 2007 to that in 2010?
Ensure brevity in your answer.  1.93. What is the ratio of the Rent(as % of GDP) in Cuba in 2007 to that in 2010?
Your answer should be very brief. 2.17. What is the ratio of the Rent(as % of GDP) in Equatorial Guinea in 2007 to that in 2010?
Provide a succinct answer. 0.79. What is the ratio of the Rent(as % of GDP) of Jordan in 2007 to that in 2010?
Keep it short and to the point. 2.95. What is the ratio of the Rent(as % of GDP) in Upper middle income in 2007 to that in 2011?
Ensure brevity in your answer.  2.06. What is the ratio of the Rent(as % of GDP) of Cuba in 2007 to that in 2011?
Make the answer very short. 2.24. What is the ratio of the Rent(as % of GDP) in Equatorial Guinea in 2007 to that in 2011?
Provide a succinct answer. 0.93. What is the ratio of the Rent(as % of GDP) of Jordan in 2007 to that in 2011?
Your answer should be compact. 2.97. What is the ratio of the Rent(as % of GDP) of Upper middle income in 2007 to that in 2012?
Make the answer very short. 2.48. What is the ratio of the Rent(as % of GDP) in Cuba in 2007 to that in 2012?
Your response must be concise. 2.89. What is the ratio of the Rent(as % of GDP) of Equatorial Guinea in 2007 to that in 2012?
Ensure brevity in your answer.  1.13. What is the ratio of the Rent(as % of GDP) of Jordan in 2007 to that in 2012?
Provide a succinct answer. 4.1. What is the ratio of the Rent(as % of GDP) in Upper middle income in 2009 to that in 2010?
Make the answer very short. 1.22. What is the ratio of the Rent(as % of GDP) of Cuba in 2009 to that in 2010?
Your response must be concise. 1.22. What is the ratio of the Rent(as % of GDP) of Equatorial Guinea in 2009 to that in 2010?
Your response must be concise. 1.26. What is the ratio of the Rent(as % of GDP) in Jordan in 2009 to that in 2010?
Give a very brief answer. 1.4. What is the ratio of the Rent(as % of GDP) of Upper middle income in 2009 to that in 2011?
Provide a short and direct response. 1.31. What is the ratio of the Rent(as % of GDP) in Cuba in 2009 to that in 2011?
Your answer should be very brief. 1.26. What is the ratio of the Rent(as % of GDP) of Equatorial Guinea in 2009 to that in 2011?
Keep it short and to the point. 1.47. What is the ratio of the Rent(as % of GDP) of Jordan in 2009 to that in 2011?
Provide a short and direct response. 1.41. What is the ratio of the Rent(as % of GDP) in Upper middle income in 2009 to that in 2012?
Offer a terse response. 1.57. What is the ratio of the Rent(as % of GDP) of Cuba in 2009 to that in 2012?
Keep it short and to the point. 1.62. What is the ratio of the Rent(as % of GDP) in Equatorial Guinea in 2009 to that in 2012?
Your answer should be very brief. 1.79. What is the ratio of the Rent(as % of GDP) in Jordan in 2009 to that in 2012?
Keep it short and to the point. 1.95. What is the ratio of the Rent(as % of GDP) of Upper middle income in 2010 to that in 2011?
Offer a terse response. 1.07. What is the ratio of the Rent(as % of GDP) in Cuba in 2010 to that in 2011?
Provide a short and direct response. 1.03. What is the ratio of the Rent(as % of GDP) in Equatorial Guinea in 2010 to that in 2011?
Provide a short and direct response. 1.17. What is the ratio of the Rent(as % of GDP) of Upper middle income in 2010 to that in 2012?
Keep it short and to the point. 1.28. What is the ratio of the Rent(as % of GDP) of Cuba in 2010 to that in 2012?
Your answer should be very brief. 1.33. What is the ratio of the Rent(as % of GDP) in Equatorial Guinea in 2010 to that in 2012?
Your answer should be compact. 1.42. What is the ratio of the Rent(as % of GDP) in Jordan in 2010 to that in 2012?
Keep it short and to the point. 1.39. What is the ratio of the Rent(as % of GDP) in Upper middle income in 2011 to that in 2012?
Give a very brief answer. 1.2. What is the ratio of the Rent(as % of GDP) in Cuba in 2011 to that in 2012?
Provide a succinct answer. 1.29. What is the ratio of the Rent(as % of GDP) in Equatorial Guinea in 2011 to that in 2012?
Make the answer very short. 1.22. What is the ratio of the Rent(as % of GDP) of Jordan in 2011 to that in 2012?
Your response must be concise. 1.38. What is the difference between the highest and the second highest Rent(as % of GDP) in Upper middle income?
Ensure brevity in your answer.  0.47. What is the difference between the highest and the second highest Rent(as % of GDP) of Cuba?
Offer a terse response. 0.19. What is the difference between the highest and the second highest Rent(as % of GDP) of Equatorial Guinea?
Your response must be concise. 2.14. What is the difference between the highest and the second highest Rent(as % of GDP) of Jordan?
Your answer should be very brief. 0.07. What is the difference between the highest and the lowest Rent(as % of GDP) of Upper middle income?
Provide a succinct answer. 0.81. What is the difference between the highest and the lowest Rent(as % of GDP) of Cuba?
Your response must be concise. 0.42. What is the difference between the highest and the lowest Rent(as % of GDP) of Equatorial Guinea?
Your answer should be very brief. 9.97. What is the difference between the highest and the lowest Rent(as % of GDP) of Jordan?
Ensure brevity in your answer.  0.2. 